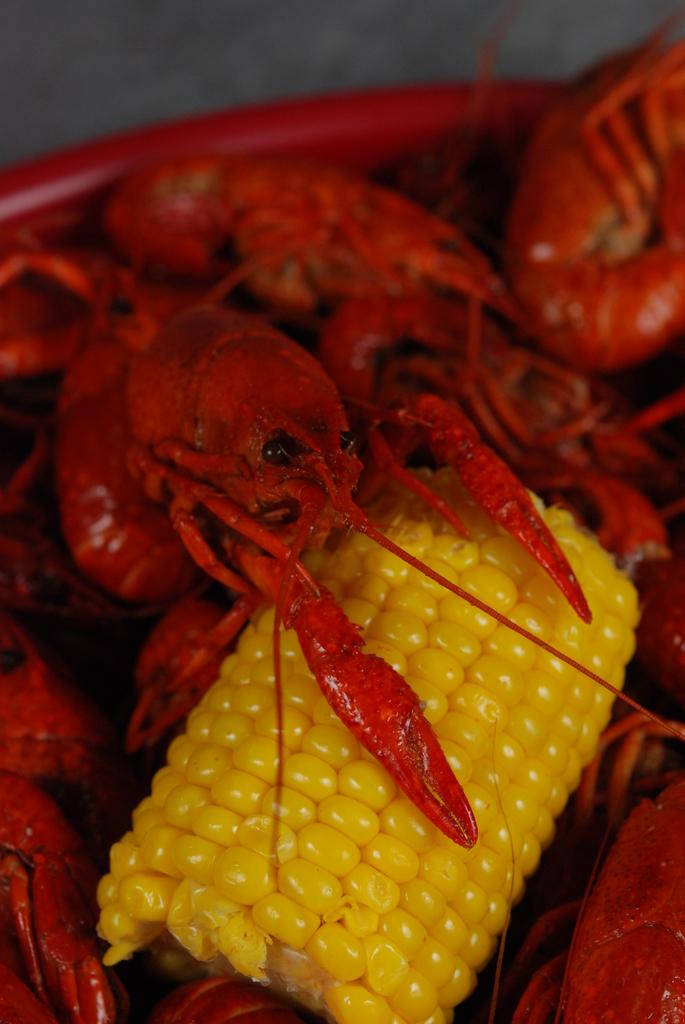What color is the bowl in the image? The bowl in the image is red. What type of food is in the bowl? There is yellow corn and red and black prawns in the bowl. How many copies of the letter "A" can be seen in the image? There are no letters or copies of letters present in the image. 